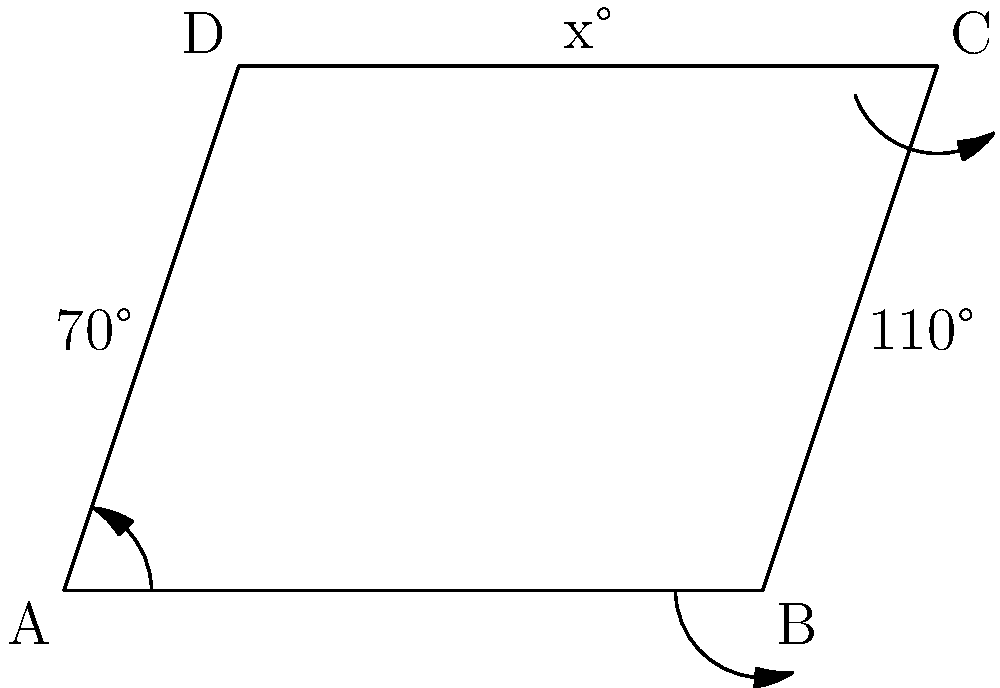In the parallelogram ABCD shown above, two angles are given: $\angle DAB = 70°$ and $\angle ABC = 110°$. What is the value of $x$, which represents $\angle BCD$? Let's approach this step-by-step:

1) In a parallelogram, opposite angles are equal. So, $\angle DAB = \angle BCD$ and $\angle ABC = \angle CDA$.

2) We're given that $\angle DAB = 70°$, so $\angle BCD = 70°$ as well.

3) We're also given that $\angle ABC = 110°$.

4) In a parallelogram (and any quadrilateral), the sum of all interior angles is always 360°.

5) Let's set up an equation:
   $\angle DAB + \angle ABC + \angle BCD + \angle CDA = 360°$

6) Substituting the known values:
   $70° + 110° + 70° + \angle CDA = 360°$

7) Simplifying:
   $250° + \angle CDA = 360°$

8) Solving for $\angle CDA$:
   $\angle CDA = 360° - 250° = 110°$

9) Therefore, $x = \angle BCD = 70°$
Answer: $70°$ 